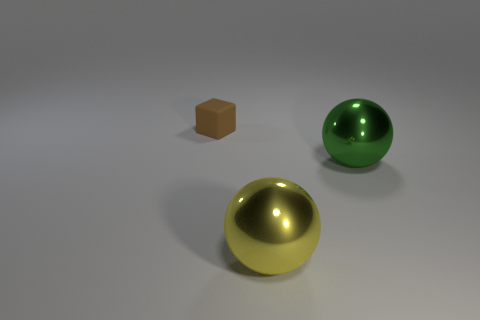Are there more tiny brown matte things behind the large yellow thing than matte objects that are on the right side of the tiny brown object?
Offer a very short reply. Yes. How many other things are there of the same material as the block?
Your answer should be compact. 0. Is the sphere in front of the green metal object made of the same material as the green ball?
Provide a succinct answer. Yes. What is the shape of the yellow metal thing?
Provide a short and direct response. Sphere. Is the number of large things that are in front of the matte object greater than the number of blue cylinders?
Your answer should be compact. Yes. Are there any other things that have the same shape as the brown matte thing?
Ensure brevity in your answer.  No. There is another large shiny thing that is the same shape as the yellow metallic thing; what color is it?
Provide a succinct answer. Green. The object that is behind the large green metallic ball has what shape?
Your response must be concise. Cube. There is a green shiny ball; are there any brown objects in front of it?
Make the answer very short. No. Is there anything else that is the same size as the brown rubber cube?
Provide a short and direct response. No. 